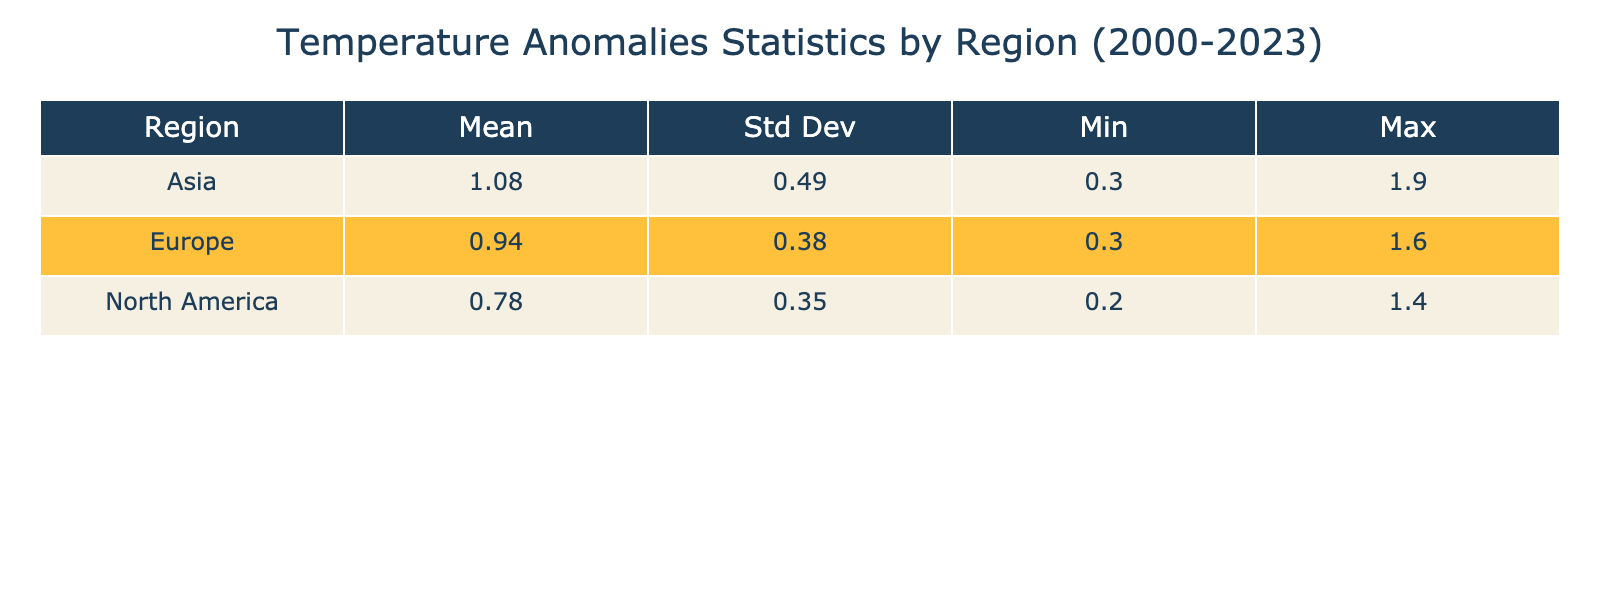What is the mean temperature anomaly for Europe from 2000 to 2023? By checking the statistics for the Europe row, we see that the Mean value for Europe is given as 1.03°C.
Answer: 1.03°C What was the maximum temperature anomaly recorded in Asia? Looking at the Asia row, the Max value is listed as 1.9°C.
Answer: 1.9°C Is the standard deviation of temperature anomalies in North America greater than that in Europe? The standard deviation for North America is 0.35 and for Europe is 0.29. Since 0.35 > 0.29, the statement is true.
Answer: Yes What was the difference between the maximum and minimum temperature anomalies in North America? The Max for North America is 1.4°C and the Min is 0.2°C. The difference is calculated as 1.4 - 0.2 = 1.2°C.
Answer: 1.2°C What is the average temperature anomaly change in Asia from 2000 to 2023? The average change can be found by comparing the values in the first and last year (1.9°C - 0.5°C = 1.4°C). Then we find the average of the yearly anomalies (sum of annual values divided by the number of years). The average over the 24 years is (0.5 + 0.4 + 0.6 + 0.7 + 0.5 + 0.9 + 0.8 + 0.8 + 0.3 + 0.5 + 1.0 + 0.9 + 1.1 + 1.3 + 1.4 + 1.5 + 1.6 + 1.2 + 1.4 + 1.5 + 1.8 + 1.6 + 1.7 + 1.9) / 24 = 1.1°C. The change from the initial point is therefore 1.1 - 0.5 = 0.6°C.
Answer: 1.4°C Did Europe’s temperature anomaly increase every year from 2000 to 2023? By examining the yearly values in Europe, we see fluctuations with decreases in 2008, 2011, and 2018, so it did not increase every year.
Answer: No 